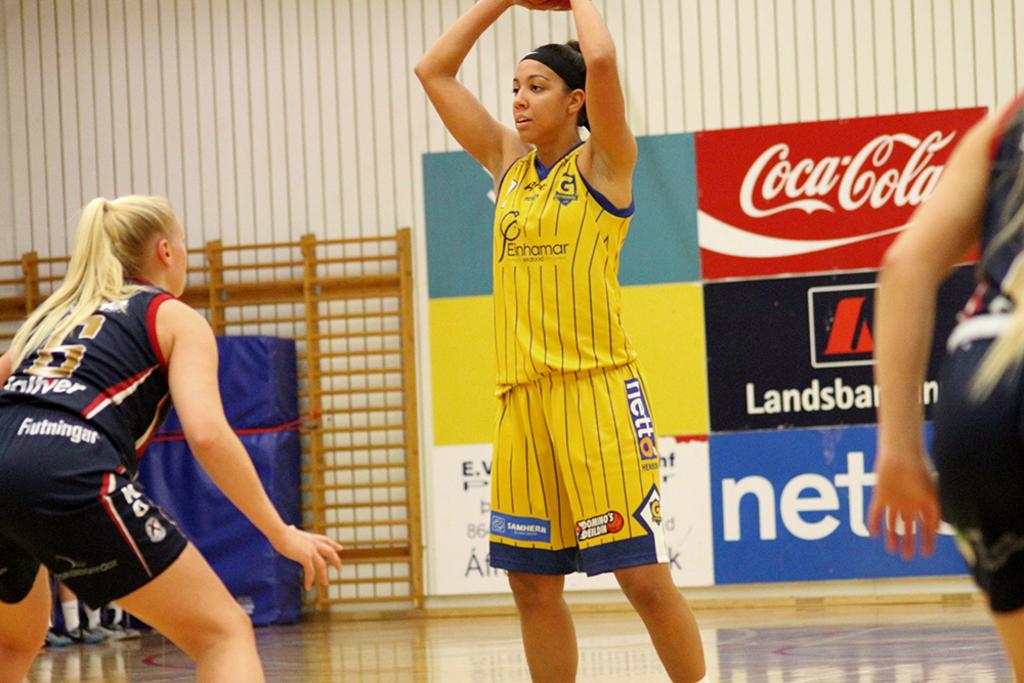Does she go to school at erhamar?
Make the answer very short. Yes. What soft drink is advertised on the red sign?
Ensure brevity in your answer.  Coca cola. 